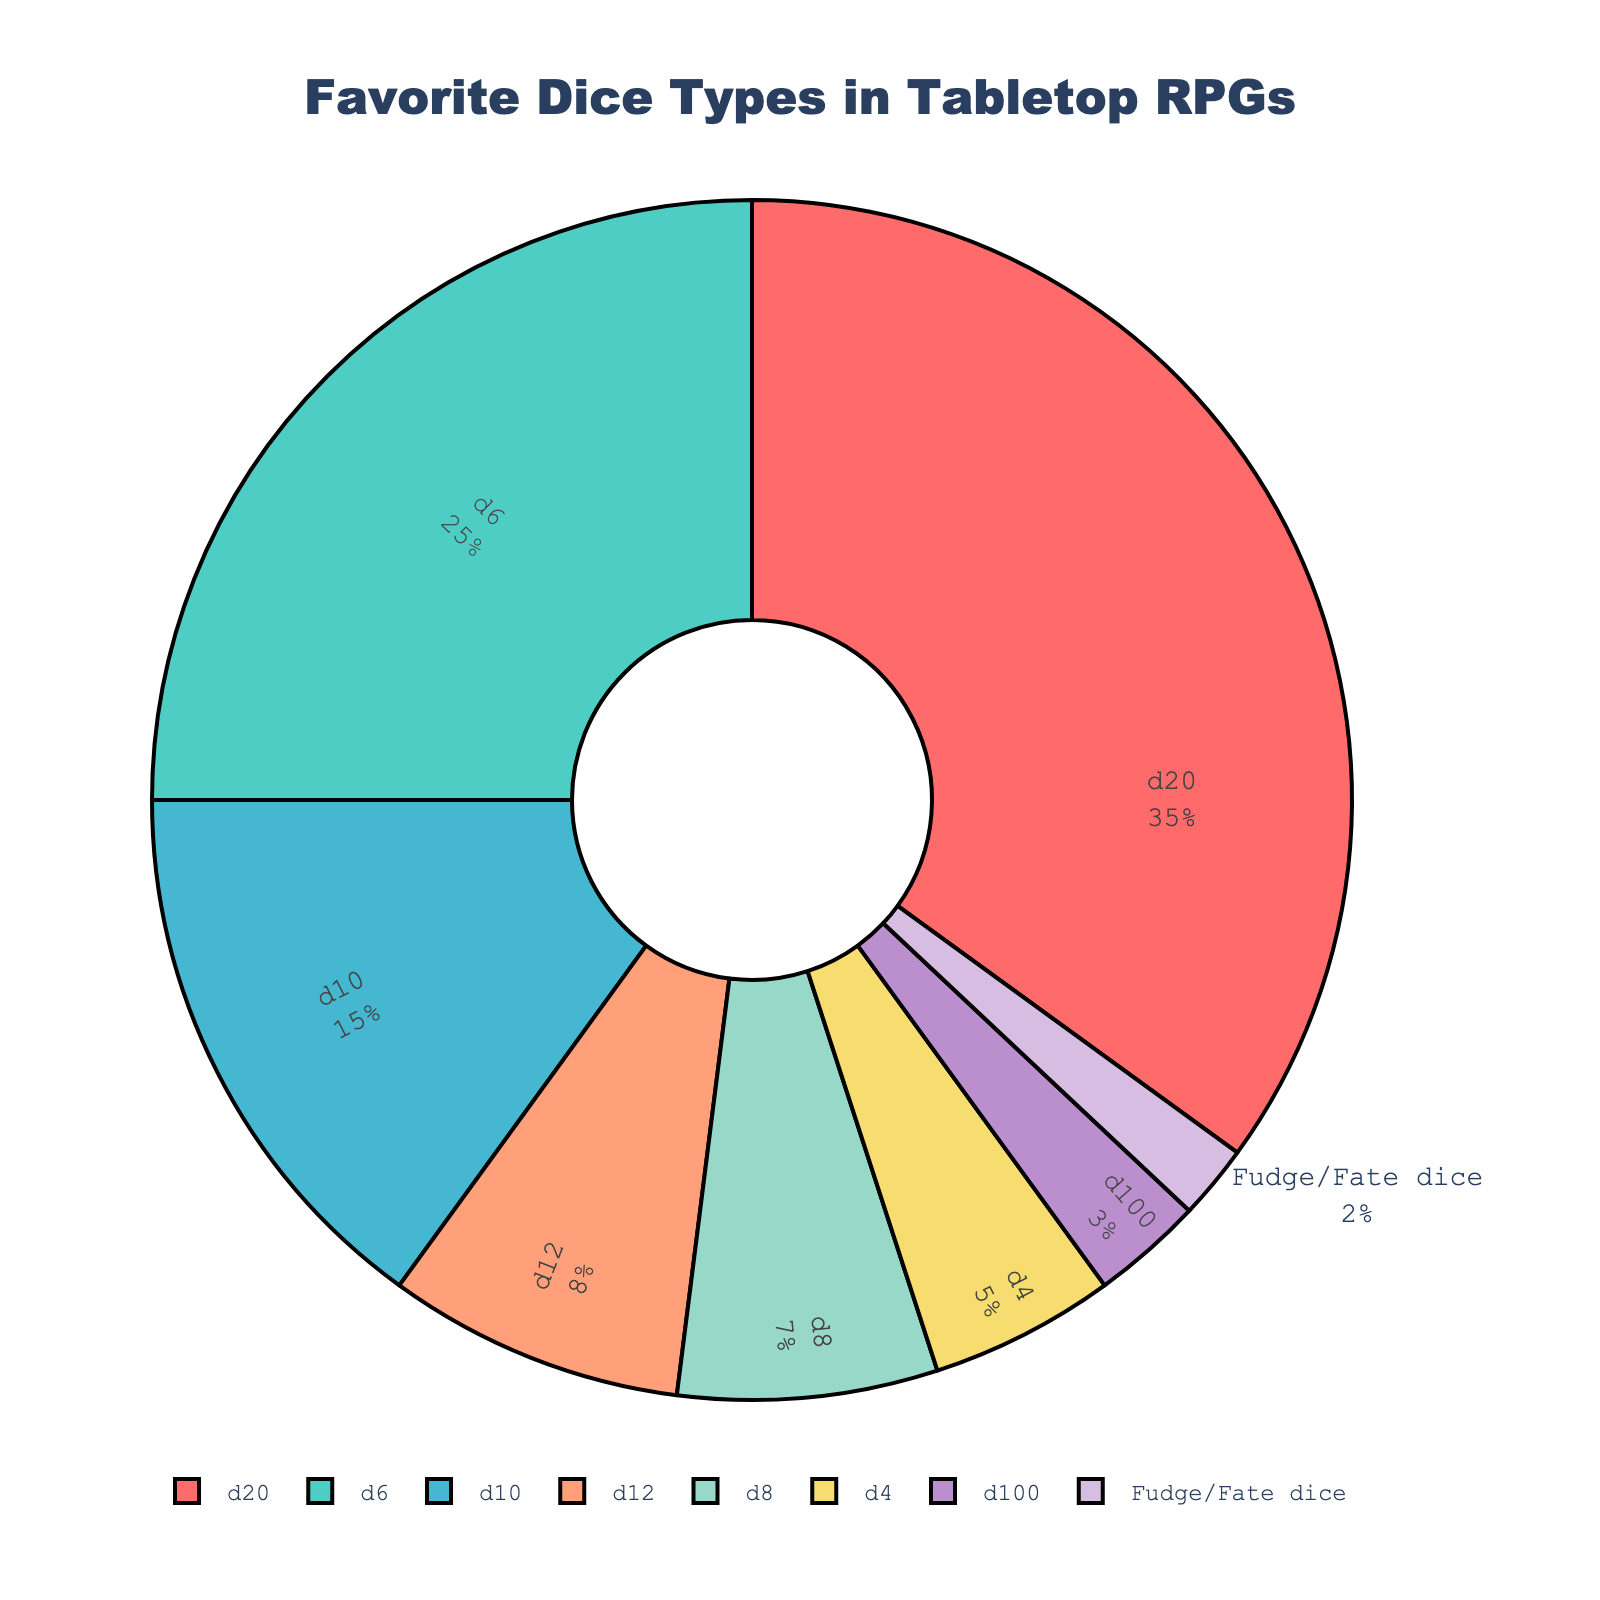what percentage of players prefer d10 over d8? According to the pie chart, d10 has a percentage of 15, while d8 has a percentage of 7. The difference is 15 - 7 = 8%.
Answer: 8% Which dice type has the least preference among players? By inspecting the chart, Fudge/Fate dice have the smallest slice, corresponding to a percentage of 2.
Answer: Fudge/Fate dice Is the sum of the percentages of d20 and d6 greater than or equal to 50%? d20 holds 35%, and d6 holds 25%. Their sum is 35 + 25 which is 60%. Since 60% is more than 50%, the answer is yes.
Answer: Yes How many dice types have a preference of less than 10%? From the chart, d10 (15%), Fudge/Fate dice (2%), d100 (3%), d12 (8%), d8 (7%), and d4 (5%) are below 10%. Counting these yields 5 types.
Answer: 5 Which dice type has a greater preference: d12 or d8? According to the chart, d12 has a percentage of 8%, whereas d8 has 7%.
Answer: d12 What is the total percentage of players that prefer dice types other than the most favored one? The most favored dice type is d20 at 35%. The other percentages are: 25 (d6) + 15 (d10) + 8 (d12) + 7 (d8) + 5 (d4) + 3 (d100) + 2 (Fudge/Fate). Summing these gives 25 + 15 + 8 + 7 + 5 + 3 + 2 = 65%.
Answer: 65% If we combine the preferences of d12 and d8, will it match or exceed the d10's popularity? d12 has 8%, and d8 has 7%. Their combined total is 8 + 7 = 15%, which equals the d10's percentage of 15%. So it matches but does not exceed.
Answer: Matches 